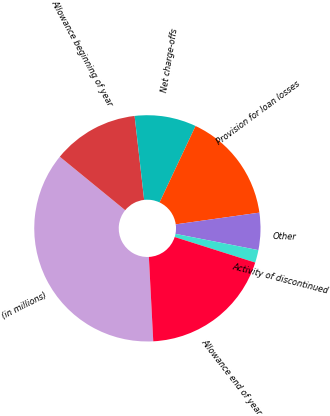Convert chart. <chart><loc_0><loc_0><loc_500><loc_500><pie_chart><fcel>(in millions)<fcel>Allowance beginning of year<fcel>Net charge-offs<fcel>Provision for loan losses<fcel>Other<fcel>Activity of discontinued<fcel>Allowance end of year<nl><fcel>36.74%<fcel>12.29%<fcel>8.8%<fcel>15.78%<fcel>5.3%<fcel>1.81%<fcel>19.28%<nl></chart> 